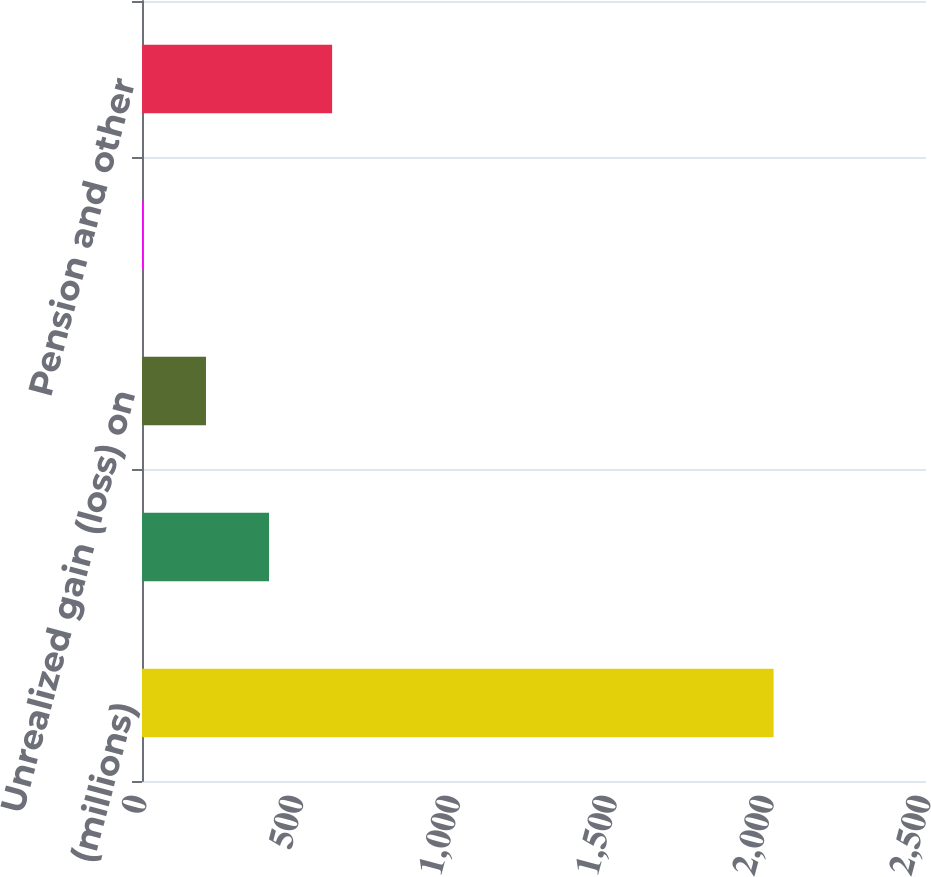<chart> <loc_0><loc_0><loc_500><loc_500><bar_chart><fcel>(millions)<fcel>Foreign currency translation<fcel>Unrealized gain (loss) on<fcel>Unamortized value of settled<fcel>Pension and other<nl><fcel>2014<fcel>405.12<fcel>204.01<fcel>2.9<fcel>606.23<nl></chart> 